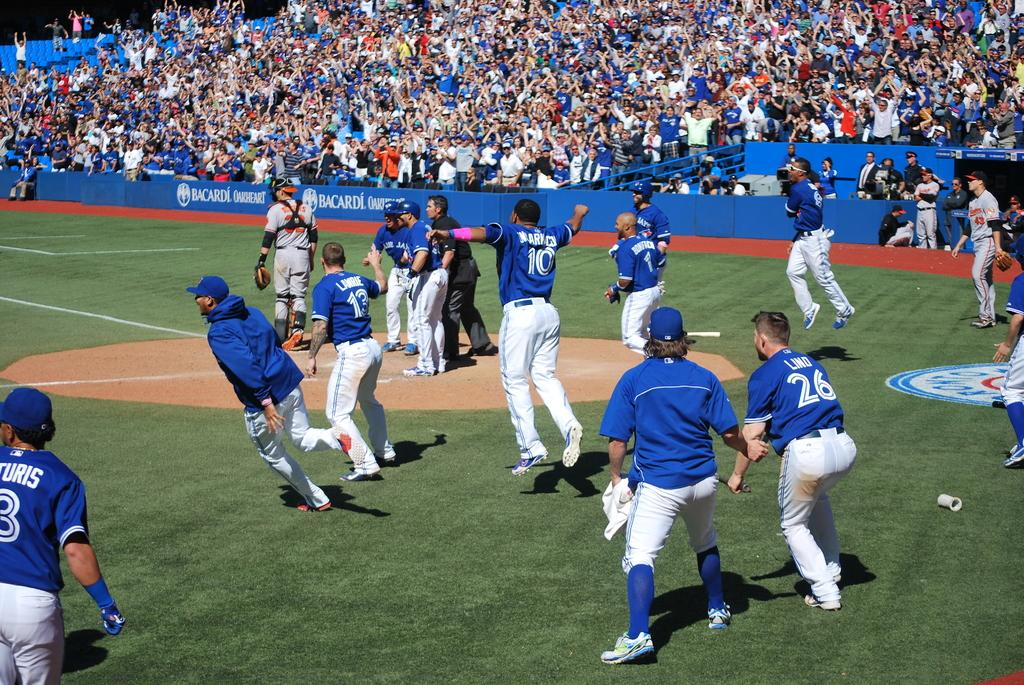Provide a one-sentence caption for the provided image. The walls of the baseball stadium are unusually uncrowded, with Bacardi being the only company advertised. 